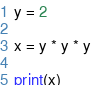Convert code to text. <code><loc_0><loc_0><loc_500><loc_500><_Python_>y = 2

x = y * y * y

print(x)
</code> 